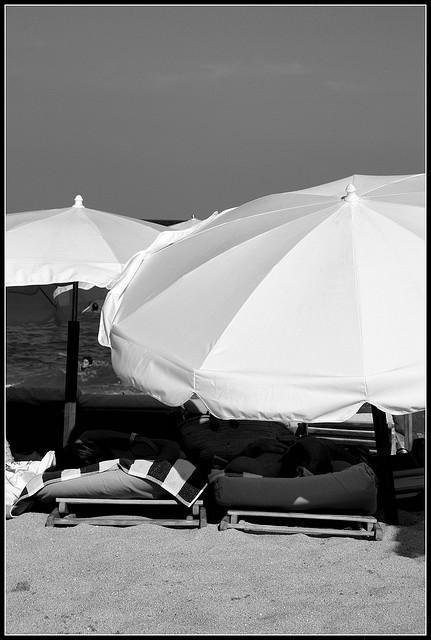How many umbrellas can you see?
Give a very brief answer. 2. 